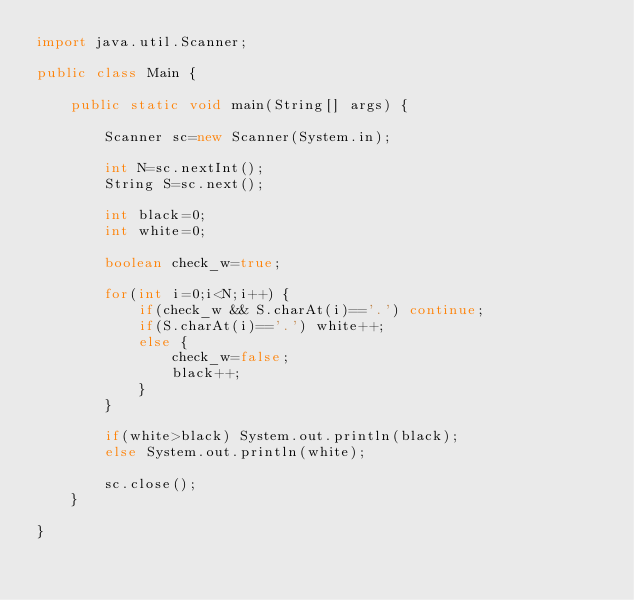<code> <loc_0><loc_0><loc_500><loc_500><_Java_>import java.util.Scanner;

public class Main {

	public static void main(String[] args) {

		Scanner sc=new Scanner(System.in);

		int N=sc.nextInt();
		String S=sc.next();

		int black=0;
		int white=0;

		boolean check_w=true;

		for(int i=0;i<N;i++) {
			if(check_w && S.charAt(i)=='.') continue;
			if(S.charAt(i)=='.') white++;
			else {
				check_w=false;
				black++;
			}
		}

		if(white>black) System.out.println(black);
		else System.out.println(white);

		sc.close();
	}

}
</code> 